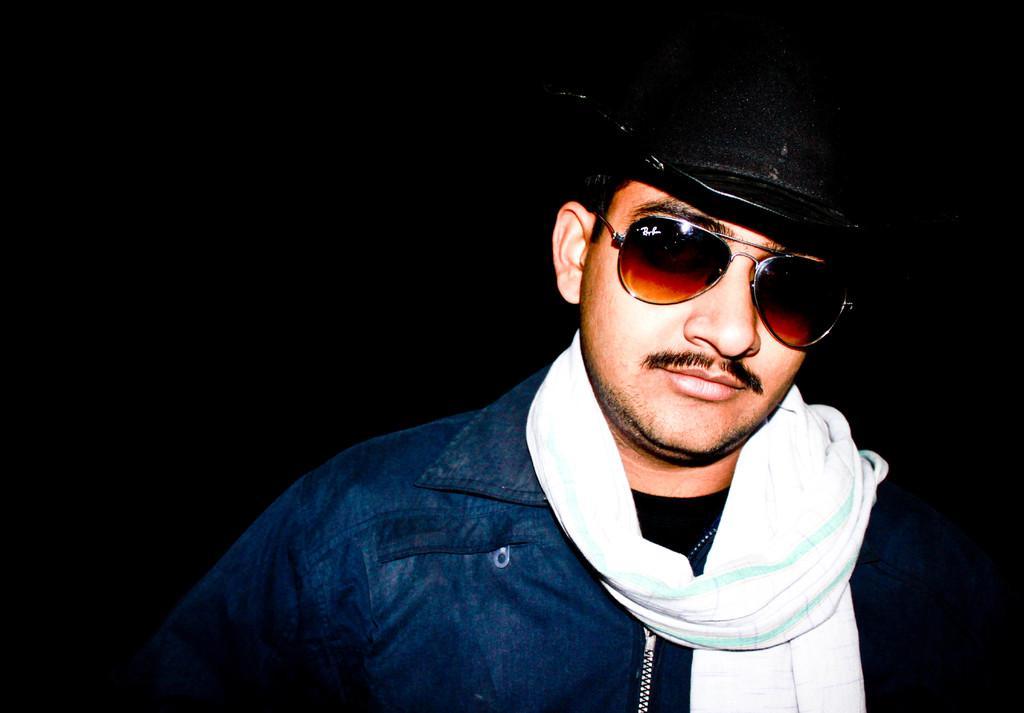In one or two sentences, can you explain what this image depicts? In this image we can see a man. 